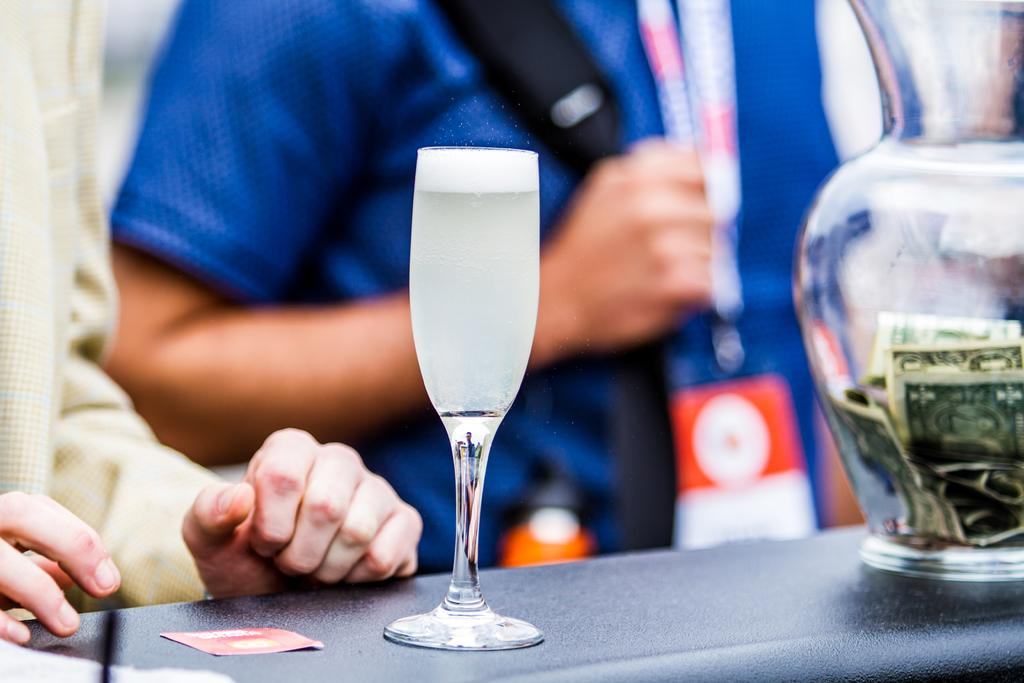How many people are in the image? There is a group of persons in the image. What is one person in the group carrying? One person is carrying a bag. What can be seen in the foreground of the image? There is a vase with currency notes and a glass in the foreground. What object is placed on a surface in the foreground? There is a card placed on a surface in the foreground. What chance does the person carrying the bag have of winning a trip in the image? There is no indication of a chance or trip in the image; it only shows a group of persons, a bag, a vase with currency notes, a glass, and a card. 